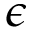<formula> <loc_0><loc_0><loc_500><loc_500>\epsilon</formula> 